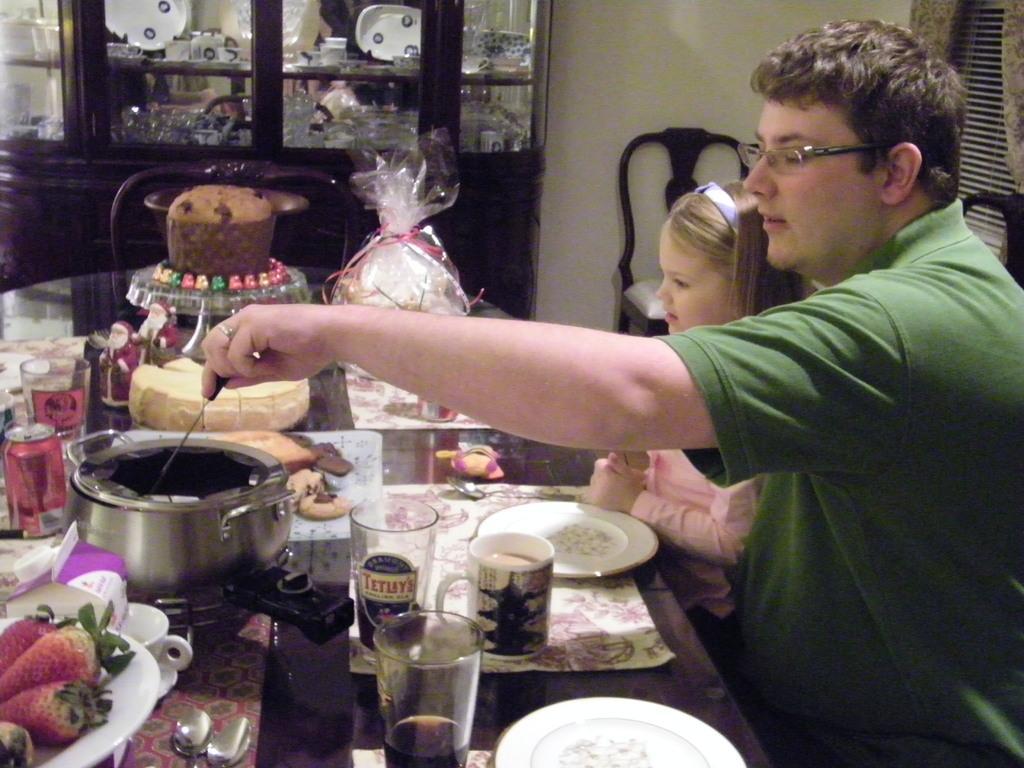Can you describe this image briefly? In this image we can see a man and child sitting on the chairs and a table is placed in front of them. On the table we can see fruits placed in the plates, glass tumblers, beverage tins, cake placed on the cake table, wrapped gifts, cutlery and a vessel. In the background we can see chairs on the floor and a cupboard with cutlery and crockery inside it. 